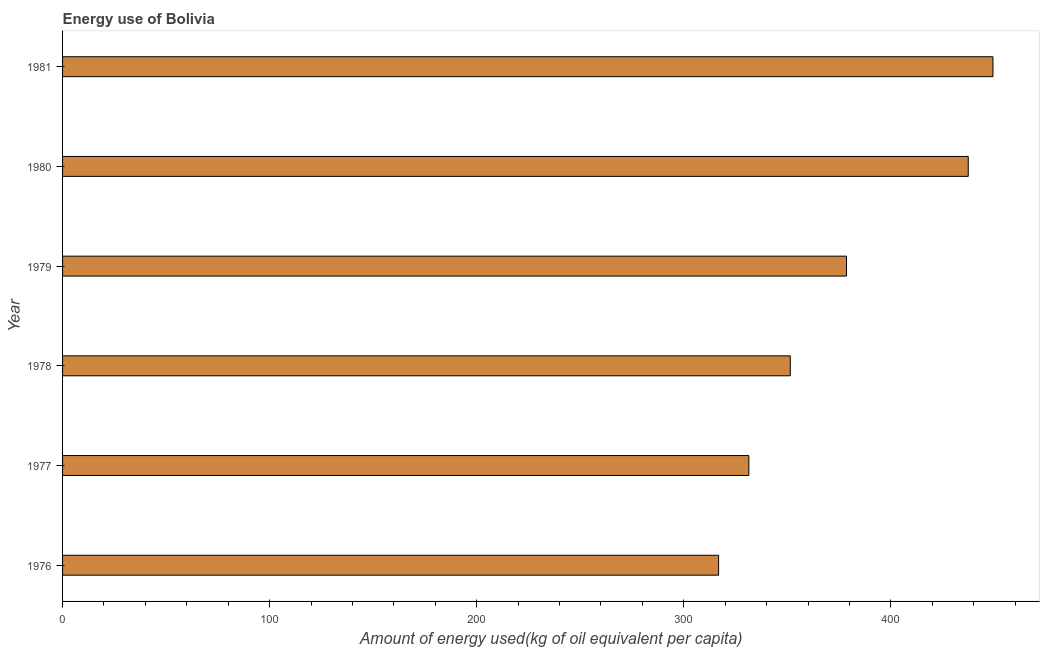Does the graph contain any zero values?
Give a very brief answer. No. What is the title of the graph?
Provide a succinct answer. Energy use of Bolivia. What is the label or title of the X-axis?
Offer a terse response. Amount of energy used(kg of oil equivalent per capita). What is the amount of energy used in 1981?
Your answer should be very brief. 449.33. Across all years, what is the maximum amount of energy used?
Provide a short and direct response. 449.33. Across all years, what is the minimum amount of energy used?
Your response must be concise. 316.82. In which year was the amount of energy used minimum?
Offer a very short reply. 1976. What is the sum of the amount of energy used?
Offer a terse response. 2265.01. What is the difference between the amount of energy used in 1977 and 1980?
Provide a succinct answer. -105.95. What is the average amount of energy used per year?
Provide a short and direct response. 377.5. What is the median amount of energy used?
Your answer should be compact. 365.02. What is the ratio of the amount of energy used in 1976 to that in 1980?
Give a very brief answer. 0.72. What is the difference between the highest and the second highest amount of energy used?
Make the answer very short. 11.94. Is the sum of the amount of energy used in 1978 and 1980 greater than the maximum amount of energy used across all years?
Provide a short and direct response. Yes. What is the difference between the highest and the lowest amount of energy used?
Your answer should be very brief. 132.5. In how many years, is the amount of energy used greater than the average amount of energy used taken over all years?
Keep it short and to the point. 3. How many years are there in the graph?
Make the answer very short. 6. What is the difference between two consecutive major ticks on the X-axis?
Offer a very short reply. 100. What is the Amount of energy used(kg of oil equivalent per capita) in 1976?
Your response must be concise. 316.82. What is the Amount of energy used(kg of oil equivalent per capita) in 1977?
Your answer should be compact. 331.44. What is the Amount of energy used(kg of oil equivalent per capita) of 1978?
Ensure brevity in your answer.  351.45. What is the Amount of energy used(kg of oil equivalent per capita) in 1979?
Make the answer very short. 378.58. What is the Amount of energy used(kg of oil equivalent per capita) of 1980?
Keep it short and to the point. 437.39. What is the Amount of energy used(kg of oil equivalent per capita) in 1981?
Give a very brief answer. 449.33. What is the difference between the Amount of energy used(kg of oil equivalent per capita) in 1976 and 1977?
Your response must be concise. -14.62. What is the difference between the Amount of energy used(kg of oil equivalent per capita) in 1976 and 1978?
Offer a terse response. -34.63. What is the difference between the Amount of energy used(kg of oil equivalent per capita) in 1976 and 1979?
Keep it short and to the point. -61.76. What is the difference between the Amount of energy used(kg of oil equivalent per capita) in 1976 and 1980?
Offer a very short reply. -120.57. What is the difference between the Amount of energy used(kg of oil equivalent per capita) in 1976 and 1981?
Your answer should be compact. -132.5. What is the difference between the Amount of energy used(kg of oil equivalent per capita) in 1977 and 1978?
Offer a very short reply. -20.01. What is the difference between the Amount of energy used(kg of oil equivalent per capita) in 1977 and 1979?
Offer a terse response. -47.14. What is the difference between the Amount of energy used(kg of oil equivalent per capita) in 1977 and 1980?
Your answer should be very brief. -105.95. What is the difference between the Amount of energy used(kg of oil equivalent per capita) in 1977 and 1981?
Offer a terse response. -117.89. What is the difference between the Amount of energy used(kg of oil equivalent per capita) in 1978 and 1979?
Keep it short and to the point. -27.13. What is the difference between the Amount of energy used(kg of oil equivalent per capita) in 1978 and 1980?
Provide a succinct answer. -85.94. What is the difference between the Amount of energy used(kg of oil equivalent per capita) in 1978 and 1981?
Your response must be concise. -97.88. What is the difference between the Amount of energy used(kg of oil equivalent per capita) in 1979 and 1980?
Your response must be concise. -58.81. What is the difference between the Amount of energy used(kg of oil equivalent per capita) in 1979 and 1981?
Provide a succinct answer. -70.75. What is the difference between the Amount of energy used(kg of oil equivalent per capita) in 1980 and 1981?
Make the answer very short. -11.94. What is the ratio of the Amount of energy used(kg of oil equivalent per capita) in 1976 to that in 1977?
Your answer should be compact. 0.96. What is the ratio of the Amount of energy used(kg of oil equivalent per capita) in 1976 to that in 1978?
Your answer should be very brief. 0.9. What is the ratio of the Amount of energy used(kg of oil equivalent per capita) in 1976 to that in 1979?
Offer a very short reply. 0.84. What is the ratio of the Amount of energy used(kg of oil equivalent per capita) in 1976 to that in 1980?
Provide a short and direct response. 0.72. What is the ratio of the Amount of energy used(kg of oil equivalent per capita) in 1976 to that in 1981?
Your response must be concise. 0.7. What is the ratio of the Amount of energy used(kg of oil equivalent per capita) in 1977 to that in 1978?
Your response must be concise. 0.94. What is the ratio of the Amount of energy used(kg of oil equivalent per capita) in 1977 to that in 1980?
Give a very brief answer. 0.76. What is the ratio of the Amount of energy used(kg of oil equivalent per capita) in 1977 to that in 1981?
Provide a short and direct response. 0.74. What is the ratio of the Amount of energy used(kg of oil equivalent per capita) in 1978 to that in 1979?
Ensure brevity in your answer.  0.93. What is the ratio of the Amount of energy used(kg of oil equivalent per capita) in 1978 to that in 1980?
Your response must be concise. 0.8. What is the ratio of the Amount of energy used(kg of oil equivalent per capita) in 1978 to that in 1981?
Make the answer very short. 0.78. What is the ratio of the Amount of energy used(kg of oil equivalent per capita) in 1979 to that in 1980?
Give a very brief answer. 0.87. What is the ratio of the Amount of energy used(kg of oil equivalent per capita) in 1979 to that in 1981?
Your answer should be very brief. 0.84. What is the ratio of the Amount of energy used(kg of oil equivalent per capita) in 1980 to that in 1981?
Your response must be concise. 0.97. 